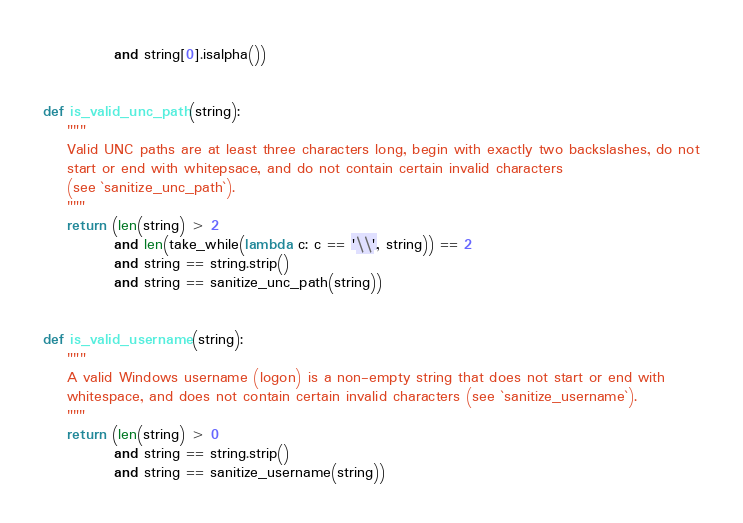Convert code to text. <code><loc_0><loc_0><loc_500><loc_500><_Python_>            and string[0].isalpha())


def is_valid_unc_path(string):
    """
    Valid UNC paths are at least three characters long, begin with exactly two backslashes, do not
    start or end with whitepsace, and do not contain certain invalid characters
    (see `sanitize_unc_path`).
    """
    return (len(string) > 2
            and len(take_while(lambda c: c == '\\', string)) == 2
            and string == string.strip()
            and string == sanitize_unc_path(string))


def is_valid_username(string):
    """
    A valid Windows username (logon) is a non-empty string that does not start or end with
    whitespace, and does not contain certain invalid characters (see `sanitize_username`).
    """
    return (len(string) > 0
            and string == string.strip()
            and string == sanitize_username(string))
</code> 